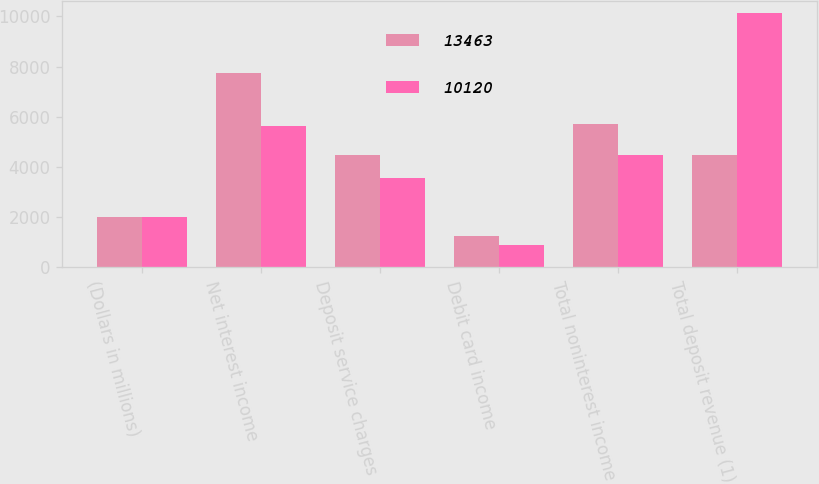<chart> <loc_0><loc_0><loc_500><loc_500><stacked_bar_chart><ecel><fcel>(Dollars in millions)<fcel>Net interest income<fcel>Deposit service charges<fcel>Debit card income<fcel>Total noninterest income<fcel>Total deposit revenue (1)<nl><fcel>13463<fcel>2004<fcel>7735<fcel>4496<fcel>1232<fcel>5728<fcel>4473<nl><fcel>10120<fcel>2003<fcel>5647<fcel>3577<fcel>896<fcel>4473<fcel>10120<nl></chart> 